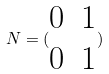Convert formula to latex. <formula><loc_0><loc_0><loc_500><loc_500>N = ( \begin{matrix} 0 & 1 \\ 0 & 1 \end{matrix} )</formula> 